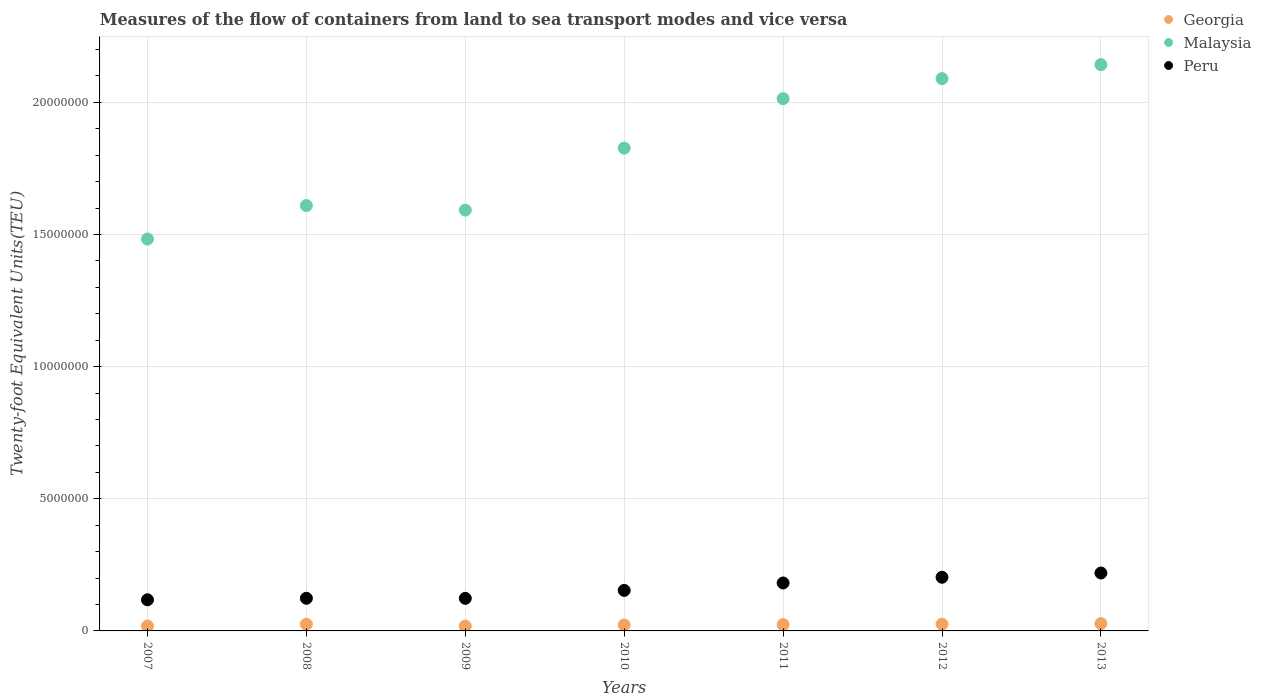How many different coloured dotlines are there?
Your answer should be very brief. 3. What is the container port traffic in Malaysia in 2013?
Your answer should be compact. 2.14e+07. Across all years, what is the maximum container port traffic in Georgia?
Offer a very short reply. 2.77e+05. Across all years, what is the minimum container port traffic in Peru?
Give a very brief answer. 1.18e+06. In which year was the container port traffic in Peru minimum?
Your response must be concise. 2007. What is the total container port traffic in Malaysia in the graph?
Offer a very short reply. 1.28e+08. What is the difference between the container port traffic in Georgia in 2010 and that in 2012?
Your answer should be very brief. -3.08e+04. What is the difference between the container port traffic in Peru in 2013 and the container port traffic in Georgia in 2007?
Ensure brevity in your answer.  2.01e+06. What is the average container port traffic in Peru per year?
Offer a terse response. 1.60e+06. In the year 2009, what is the difference between the container port traffic in Peru and container port traffic in Georgia?
Your answer should be very brief. 1.05e+06. What is the ratio of the container port traffic in Malaysia in 2010 to that in 2011?
Your answer should be compact. 0.91. Is the container port traffic in Georgia in 2010 less than that in 2011?
Keep it short and to the point. Yes. What is the difference between the highest and the second highest container port traffic in Malaysia?
Provide a succinct answer. 5.29e+05. What is the difference between the highest and the lowest container port traffic in Georgia?
Your response must be concise. 9.56e+04. In how many years, is the container port traffic in Georgia greater than the average container port traffic in Georgia taken over all years?
Provide a short and direct response. 4. Is it the case that in every year, the sum of the container port traffic in Peru and container port traffic in Malaysia  is greater than the container port traffic in Georgia?
Your response must be concise. Yes. Is the container port traffic in Georgia strictly greater than the container port traffic in Peru over the years?
Your answer should be very brief. No. How many dotlines are there?
Your answer should be compact. 3. Does the graph contain any zero values?
Make the answer very short. No. Does the graph contain grids?
Make the answer very short. Yes. Where does the legend appear in the graph?
Offer a terse response. Top right. How many legend labels are there?
Your answer should be compact. 3. What is the title of the graph?
Give a very brief answer. Measures of the flow of containers from land to sea transport modes and vice versa. What is the label or title of the Y-axis?
Offer a terse response. Twenty-foot Equivalent Units(TEU). What is the Twenty-foot Equivalent Units(TEU) of Georgia in 2007?
Provide a succinct answer. 1.85e+05. What is the Twenty-foot Equivalent Units(TEU) of Malaysia in 2007?
Keep it short and to the point. 1.48e+07. What is the Twenty-foot Equivalent Units(TEU) of Peru in 2007?
Provide a succinct answer. 1.18e+06. What is the Twenty-foot Equivalent Units(TEU) of Georgia in 2008?
Your answer should be compact. 2.54e+05. What is the Twenty-foot Equivalent Units(TEU) of Malaysia in 2008?
Offer a terse response. 1.61e+07. What is the Twenty-foot Equivalent Units(TEU) in Peru in 2008?
Offer a very short reply. 1.24e+06. What is the Twenty-foot Equivalent Units(TEU) of Georgia in 2009?
Your answer should be very brief. 1.82e+05. What is the Twenty-foot Equivalent Units(TEU) of Malaysia in 2009?
Your answer should be compact. 1.59e+07. What is the Twenty-foot Equivalent Units(TEU) in Peru in 2009?
Make the answer very short. 1.23e+06. What is the Twenty-foot Equivalent Units(TEU) of Georgia in 2010?
Provide a succinct answer. 2.26e+05. What is the Twenty-foot Equivalent Units(TEU) of Malaysia in 2010?
Provide a succinct answer. 1.83e+07. What is the Twenty-foot Equivalent Units(TEU) of Peru in 2010?
Make the answer very short. 1.53e+06. What is the Twenty-foot Equivalent Units(TEU) in Georgia in 2011?
Give a very brief answer. 2.39e+05. What is the Twenty-foot Equivalent Units(TEU) in Malaysia in 2011?
Give a very brief answer. 2.01e+07. What is the Twenty-foot Equivalent Units(TEU) of Peru in 2011?
Make the answer very short. 1.81e+06. What is the Twenty-foot Equivalent Units(TEU) of Georgia in 2012?
Offer a very short reply. 2.57e+05. What is the Twenty-foot Equivalent Units(TEU) in Malaysia in 2012?
Give a very brief answer. 2.09e+07. What is the Twenty-foot Equivalent Units(TEU) of Peru in 2012?
Provide a succinct answer. 2.03e+06. What is the Twenty-foot Equivalent Units(TEU) in Georgia in 2013?
Provide a succinct answer. 2.77e+05. What is the Twenty-foot Equivalent Units(TEU) of Malaysia in 2013?
Keep it short and to the point. 2.14e+07. What is the Twenty-foot Equivalent Units(TEU) in Peru in 2013?
Provide a short and direct response. 2.19e+06. Across all years, what is the maximum Twenty-foot Equivalent Units(TEU) of Georgia?
Your response must be concise. 2.77e+05. Across all years, what is the maximum Twenty-foot Equivalent Units(TEU) of Malaysia?
Ensure brevity in your answer.  2.14e+07. Across all years, what is the maximum Twenty-foot Equivalent Units(TEU) of Peru?
Provide a succinct answer. 2.19e+06. Across all years, what is the minimum Twenty-foot Equivalent Units(TEU) in Georgia?
Your response must be concise. 1.82e+05. Across all years, what is the minimum Twenty-foot Equivalent Units(TEU) of Malaysia?
Provide a short and direct response. 1.48e+07. Across all years, what is the minimum Twenty-foot Equivalent Units(TEU) of Peru?
Give a very brief answer. 1.18e+06. What is the total Twenty-foot Equivalent Units(TEU) of Georgia in the graph?
Give a very brief answer. 1.62e+06. What is the total Twenty-foot Equivalent Units(TEU) of Malaysia in the graph?
Offer a very short reply. 1.28e+08. What is the total Twenty-foot Equivalent Units(TEU) of Peru in the graph?
Give a very brief answer. 1.12e+07. What is the difference between the Twenty-foot Equivalent Units(TEU) of Georgia in 2007 and that in 2008?
Provide a succinct answer. -6.90e+04. What is the difference between the Twenty-foot Equivalent Units(TEU) of Malaysia in 2007 and that in 2008?
Provide a short and direct response. -1.27e+06. What is the difference between the Twenty-foot Equivalent Units(TEU) of Peru in 2007 and that in 2008?
Your response must be concise. -5.74e+04. What is the difference between the Twenty-foot Equivalent Units(TEU) of Georgia in 2007 and that in 2009?
Offer a very short reply. 3179. What is the difference between the Twenty-foot Equivalent Units(TEU) in Malaysia in 2007 and that in 2009?
Provide a short and direct response. -1.09e+06. What is the difference between the Twenty-foot Equivalent Units(TEU) of Peru in 2007 and that in 2009?
Ensure brevity in your answer.  -5.49e+04. What is the difference between the Twenty-foot Equivalent Units(TEU) of Georgia in 2007 and that in 2010?
Your answer should be very brief. -4.13e+04. What is the difference between the Twenty-foot Equivalent Units(TEU) in Malaysia in 2007 and that in 2010?
Provide a short and direct response. -3.44e+06. What is the difference between the Twenty-foot Equivalent Units(TEU) of Peru in 2007 and that in 2010?
Offer a very short reply. -3.56e+05. What is the difference between the Twenty-foot Equivalent Units(TEU) in Georgia in 2007 and that in 2011?
Give a very brief answer. -5.42e+04. What is the difference between the Twenty-foot Equivalent Units(TEU) of Malaysia in 2007 and that in 2011?
Provide a succinct answer. -5.31e+06. What is the difference between the Twenty-foot Equivalent Units(TEU) of Peru in 2007 and that in 2011?
Your answer should be very brief. -6.37e+05. What is the difference between the Twenty-foot Equivalent Units(TEU) in Georgia in 2007 and that in 2012?
Provide a short and direct response. -7.21e+04. What is the difference between the Twenty-foot Equivalent Units(TEU) of Malaysia in 2007 and that in 2012?
Provide a succinct answer. -6.07e+06. What is the difference between the Twenty-foot Equivalent Units(TEU) in Peru in 2007 and that in 2012?
Offer a terse response. -8.53e+05. What is the difference between the Twenty-foot Equivalent Units(TEU) in Georgia in 2007 and that in 2013?
Give a very brief answer. -9.24e+04. What is the difference between the Twenty-foot Equivalent Units(TEU) of Malaysia in 2007 and that in 2013?
Offer a terse response. -6.60e+06. What is the difference between the Twenty-foot Equivalent Units(TEU) in Peru in 2007 and that in 2013?
Your answer should be very brief. -1.01e+06. What is the difference between the Twenty-foot Equivalent Units(TEU) of Georgia in 2008 and that in 2009?
Your response must be concise. 7.22e+04. What is the difference between the Twenty-foot Equivalent Units(TEU) in Malaysia in 2008 and that in 2009?
Ensure brevity in your answer.  1.71e+05. What is the difference between the Twenty-foot Equivalent Units(TEU) in Peru in 2008 and that in 2009?
Ensure brevity in your answer.  2477. What is the difference between the Twenty-foot Equivalent Units(TEU) in Georgia in 2008 and that in 2010?
Your answer should be compact. 2.77e+04. What is the difference between the Twenty-foot Equivalent Units(TEU) of Malaysia in 2008 and that in 2010?
Provide a succinct answer. -2.17e+06. What is the difference between the Twenty-foot Equivalent Units(TEU) in Peru in 2008 and that in 2010?
Provide a succinct answer. -2.99e+05. What is the difference between the Twenty-foot Equivalent Units(TEU) in Georgia in 2008 and that in 2011?
Ensure brevity in your answer.  1.48e+04. What is the difference between the Twenty-foot Equivalent Units(TEU) of Malaysia in 2008 and that in 2011?
Make the answer very short. -4.05e+06. What is the difference between the Twenty-foot Equivalent Units(TEU) in Peru in 2008 and that in 2011?
Provide a succinct answer. -5.79e+05. What is the difference between the Twenty-foot Equivalent Units(TEU) in Georgia in 2008 and that in 2012?
Offer a terse response. -3117.82. What is the difference between the Twenty-foot Equivalent Units(TEU) of Malaysia in 2008 and that in 2012?
Give a very brief answer. -4.80e+06. What is the difference between the Twenty-foot Equivalent Units(TEU) in Peru in 2008 and that in 2012?
Provide a succinct answer. -7.96e+05. What is the difference between the Twenty-foot Equivalent Units(TEU) of Georgia in 2008 and that in 2013?
Offer a very short reply. -2.34e+04. What is the difference between the Twenty-foot Equivalent Units(TEU) in Malaysia in 2008 and that in 2013?
Your response must be concise. -5.33e+06. What is the difference between the Twenty-foot Equivalent Units(TEU) of Peru in 2008 and that in 2013?
Ensure brevity in your answer.  -9.56e+05. What is the difference between the Twenty-foot Equivalent Units(TEU) of Georgia in 2009 and that in 2010?
Provide a short and direct response. -4.45e+04. What is the difference between the Twenty-foot Equivalent Units(TEU) in Malaysia in 2009 and that in 2010?
Your answer should be compact. -2.34e+06. What is the difference between the Twenty-foot Equivalent Units(TEU) of Peru in 2009 and that in 2010?
Offer a terse response. -3.01e+05. What is the difference between the Twenty-foot Equivalent Units(TEU) of Georgia in 2009 and that in 2011?
Your answer should be very brief. -5.74e+04. What is the difference between the Twenty-foot Equivalent Units(TEU) of Malaysia in 2009 and that in 2011?
Make the answer very short. -4.22e+06. What is the difference between the Twenty-foot Equivalent Units(TEU) of Peru in 2009 and that in 2011?
Keep it short and to the point. -5.82e+05. What is the difference between the Twenty-foot Equivalent Units(TEU) of Georgia in 2009 and that in 2012?
Provide a short and direct response. -7.53e+04. What is the difference between the Twenty-foot Equivalent Units(TEU) in Malaysia in 2009 and that in 2012?
Offer a very short reply. -4.97e+06. What is the difference between the Twenty-foot Equivalent Units(TEU) in Peru in 2009 and that in 2012?
Offer a terse response. -7.98e+05. What is the difference between the Twenty-foot Equivalent Units(TEU) of Georgia in 2009 and that in 2013?
Offer a very short reply. -9.56e+04. What is the difference between the Twenty-foot Equivalent Units(TEU) of Malaysia in 2009 and that in 2013?
Offer a very short reply. -5.50e+06. What is the difference between the Twenty-foot Equivalent Units(TEU) of Peru in 2009 and that in 2013?
Provide a succinct answer. -9.59e+05. What is the difference between the Twenty-foot Equivalent Units(TEU) in Georgia in 2010 and that in 2011?
Make the answer very short. -1.29e+04. What is the difference between the Twenty-foot Equivalent Units(TEU) in Malaysia in 2010 and that in 2011?
Keep it short and to the point. -1.87e+06. What is the difference between the Twenty-foot Equivalent Units(TEU) in Peru in 2010 and that in 2011?
Give a very brief answer. -2.81e+05. What is the difference between the Twenty-foot Equivalent Units(TEU) in Georgia in 2010 and that in 2012?
Make the answer very short. -3.08e+04. What is the difference between the Twenty-foot Equivalent Units(TEU) of Malaysia in 2010 and that in 2012?
Provide a short and direct response. -2.63e+06. What is the difference between the Twenty-foot Equivalent Units(TEU) of Peru in 2010 and that in 2012?
Ensure brevity in your answer.  -4.97e+05. What is the difference between the Twenty-foot Equivalent Units(TEU) in Georgia in 2010 and that in 2013?
Ensure brevity in your answer.  -5.11e+04. What is the difference between the Twenty-foot Equivalent Units(TEU) in Malaysia in 2010 and that in 2013?
Provide a succinct answer. -3.16e+06. What is the difference between the Twenty-foot Equivalent Units(TEU) of Peru in 2010 and that in 2013?
Keep it short and to the point. -6.58e+05. What is the difference between the Twenty-foot Equivalent Units(TEU) of Georgia in 2011 and that in 2012?
Your answer should be very brief. -1.79e+04. What is the difference between the Twenty-foot Equivalent Units(TEU) in Malaysia in 2011 and that in 2012?
Offer a very short reply. -7.58e+05. What is the difference between the Twenty-foot Equivalent Units(TEU) in Peru in 2011 and that in 2012?
Your answer should be compact. -2.16e+05. What is the difference between the Twenty-foot Equivalent Units(TEU) of Georgia in 2011 and that in 2013?
Give a very brief answer. -3.82e+04. What is the difference between the Twenty-foot Equivalent Units(TEU) in Malaysia in 2011 and that in 2013?
Make the answer very short. -1.29e+06. What is the difference between the Twenty-foot Equivalent Units(TEU) of Peru in 2011 and that in 2013?
Offer a terse response. -3.77e+05. What is the difference between the Twenty-foot Equivalent Units(TEU) in Georgia in 2012 and that in 2013?
Keep it short and to the point. -2.03e+04. What is the difference between the Twenty-foot Equivalent Units(TEU) of Malaysia in 2012 and that in 2013?
Offer a very short reply. -5.29e+05. What is the difference between the Twenty-foot Equivalent Units(TEU) in Peru in 2012 and that in 2013?
Offer a terse response. -1.60e+05. What is the difference between the Twenty-foot Equivalent Units(TEU) in Georgia in 2007 and the Twenty-foot Equivalent Units(TEU) in Malaysia in 2008?
Your response must be concise. -1.59e+07. What is the difference between the Twenty-foot Equivalent Units(TEU) of Georgia in 2007 and the Twenty-foot Equivalent Units(TEU) of Peru in 2008?
Provide a succinct answer. -1.05e+06. What is the difference between the Twenty-foot Equivalent Units(TEU) in Malaysia in 2007 and the Twenty-foot Equivalent Units(TEU) in Peru in 2008?
Provide a succinct answer. 1.36e+07. What is the difference between the Twenty-foot Equivalent Units(TEU) in Georgia in 2007 and the Twenty-foot Equivalent Units(TEU) in Malaysia in 2009?
Your answer should be compact. -1.57e+07. What is the difference between the Twenty-foot Equivalent Units(TEU) in Georgia in 2007 and the Twenty-foot Equivalent Units(TEU) in Peru in 2009?
Make the answer very short. -1.05e+06. What is the difference between the Twenty-foot Equivalent Units(TEU) in Malaysia in 2007 and the Twenty-foot Equivalent Units(TEU) in Peru in 2009?
Offer a terse response. 1.36e+07. What is the difference between the Twenty-foot Equivalent Units(TEU) of Georgia in 2007 and the Twenty-foot Equivalent Units(TEU) of Malaysia in 2010?
Provide a succinct answer. -1.81e+07. What is the difference between the Twenty-foot Equivalent Units(TEU) of Georgia in 2007 and the Twenty-foot Equivalent Units(TEU) of Peru in 2010?
Provide a short and direct response. -1.35e+06. What is the difference between the Twenty-foot Equivalent Units(TEU) in Malaysia in 2007 and the Twenty-foot Equivalent Units(TEU) in Peru in 2010?
Offer a terse response. 1.33e+07. What is the difference between the Twenty-foot Equivalent Units(TEU) in Georgia in 2007 and the Twenty-foot Equivalent Units(TEU) in Malaysia in 2011?
Provide a succinct answer. -2.00e+07. What is the difference between the Twenty-foot Equivalent Units(TEU) of Georgia in 2007 and the Twenty-foot Equivalent Units(TEU) of Peru in 2011?
Provide a short and direct response. -1.63e+06. What is the difference between the Twenty-foot Equivalent Units(TEU) in Malaysia in 2007 and the Twenty-foot Equivalent Units(TEU) in Peru in 2011?
Your response must be concise. 1.30e+07. What is the difference between the Twenty-foot Equivalent Units(TEU) of Georgia in 2007 and the Twenty-foot Equivalent Units(TEU) of Malaysia in 2012?
Keep it short and to the point. -2.07e+07. What is the difference between the Twenty-foot Equivalent Units(TEU) in Georgia in 2007 and the Twenty-foot Equivalent Units(TEU) in Peru in 2012?
Offer a terse response. -1.85e+06. What is the difference between the Twenty-foot Equivalent Units(TEU) in Malaysia in 2007 and the Twenty-foot Equivalent Units(TEU) in Peru in 2012?
Your answer should be very brief. 1.28e+07. What is the difference between the Twenty-foot Equivalent Units(TEU) in Georgia in 2007 and the Twenty-foot Equivalent Units(TEU) in Malaysia in 2013?
Offer a terse response. -2.12e+07. What is the difference between the Twenty-foot Equivalent Units(TEU) of Georgia in 2007 and the Twenty-foot Equivalent Units(TEU) of Peru in 2013?
Ensure brevity in your answer.  -2.01e+06. What is the difference between the Twenty-foot Equivalent Units(TEU) of Malaysia in 2007 and the Twenty-foot Equivalent Units(TEU) of Peru in 2013?
Make the answer very short. 1.26e+07. What is the difference between the Twenty-foot Equivalent Units(TEU) in Georgia in 2008 and the Twenty-foot Equivalent Units(TEU) in Malaysia in 2009?
Keep it short and to the point. -1.57e+07. What is the difference between the Twenty-foot Equivalent Units(TEU) in Georgia in 2008 and the Twenty-foot Equivalent Units(TEU) in Peru in 2009?
Give a very brief answer. -9.79e+05. What is the difference between the Twenty-foot Equivalent Units(TEU) in Malaysia in 2008 and the Twenty-foot Equivalent Units(TEU) in Peru in 2009?
Provide a short and direct response. 1.49e+07. What is the difference between the Twenty-foot Equivalent Units(TEU) of Georgia in 2008 and the Twenty-foot Equivalent Units(TEU) of Malaysia in 2010?
Provide a short and direct response. -1.80e+07. What is the difference between the Twenty-foot Equivalent Units(TEU) in Georgia in 2008 and the Twenty-foot Equivalent Units(TEU) in Peru in 2010?
Offer a terse response. -1.28e+06. What is the difference between the Twenty-foot Equivalent Units(TEU) in Malaysia in 2008 and the Twenty-foot Equivalent Units(TEU) in Peru in 2010?
Offer a very short reply. 1.46e+07. What is the difference between the Twenty-foot Equivalent Units(TEU) in Georgia in 2008 and the Twenty-foot Equivalent Units(TEU) in Malaysia in 2011?
Offer a very short reply. -1.99e+07. What is the difference between the Twenty-foot Equivalent Units(TEU) of Georgia in 2008 and the Twenty-foot Equivalent Units(TEU) of Peru in 2011?
Provide a succinct answer. -1.56e+06. What is the difference between the Twenty-foot Equivalent Units(TEU) in Malaysia in 2008 and the Twenty-foot Equivalent Units(TEU) in Peru in 2011?
Ensure brevity in your answer.  1.43e+07. What is the difference between the Twenty-foot Equivalent Units(TEU) in Georgia in 2008 and the Twenty-foot Equivalent Units(TEU) in Malaysia in 2012?
Offer a very short reply. -2.06e+07. What is the difference between the Twenty-foot Equivalent Units(TEU) in Georgia in 2008 and the Twenty-foot Equivalent Units(TEU) in Peru in 2012?
Your response must be concise. -1.78e+06. What is the difference between the Twenty-foot Equivalent Units(TEU) of Malaysia in 2008 and the Twenty-foot Equivalent Units(TEU) of Peru in 2012?
Your answer should be compact. 1.41e+07. What is the difference between the Twenty-foot Equivalent Units(TEU) in Georgia in 2008 and the Twenty-foot Equivalent Units(TEU) in Malaysia in 2013?
Provide a succinct answer. -2.12e+07. What is the difference between the Twenty-foot Equivalent Units(TEU) in Georgia in 2008 and the Twenty-foot Equivalent Units(TEU) in Peru in 2013?
Ensure brevity in your answer.  -1.94e+06. What is the difference between the Twenty-foot Equivalent Units(TEU) of Malaysia in 2008 and the Twenty-foot Equivalent Units(TEU) of Peru in 2013?
Keep it short and to the point. 1.39e+07. What is the difference between the Twenty-foot Equivalent Units(TEU) in Georgia in 2009 and the Twenty-foot Equivalent Units(TEU) in Malaysia in 2010?
Make the answer very short. -1.81e+07. What is the difference between the Twenty-foot Equivalent Units(TEU) in Georgia in 2009 and the Twenty-foot Equivalent Units(TEU) in Peru in 2010?
Provide a succinct answer. -1.35e+06. What is the difference between the Twenty-foot Equivalent Units(TEU) in Malaysia in 2009 and the Twenty-foot Equivalent Units(TEU) in Peru in 2010?
Offer a terse response. 1.44e+07. What is the difference between the Twenty-foot Equivalent Units(TEU) of Georgia in 2009 and the Twenty-foot Equivalent Units(TEU) of Malaysia in 2011?
Keep it short and to the point. -2.00e+07. What is the difference between the Twenty-foot Equivalent Units(TEU) in Georgia in 2009 and the Twenty-foot Equivalent Units(TEU) in Peru in 2011?
Make the answer very short. -1.63e+06. What is the difference between the Twenty-foot Equivalent Units(TEU) of Malaysia in 2009 and the Twenty-foot Equivalent Units(TEU) of Peru in 2011?
Your answer should be compact. 1.41e+07. What is the difference between the Twenty-foot Equivalent Units(TEU) in Georgia in 2009 and the Twenty-foot Equivalent Units(TEU) in Malaysia in 2012?
Keep it short and to the point. -2.07e+07. What is the difference between the Twenty-foot Equivalent Units(TEU) in Georgia in 2009 and the Twenty-foot Equivalent Units(TEU) in Peru in 2012?
Give a very brief answer. -1.85e+06. What is the difference between the Twenty-foot Equivalent Units(TEU) in Malaysia in 2009 and the Twenty-foot Equivalent Units(TEU) in Peru in 2012?
Keep it short and to the point. 1.39e+07. What is the difference between the Twenty-foot Equivalent Units(TEU) in Georgia in 2009 and the Twenty-foot Equivalent Units(TEU) in Malaysia in 2013?
Your response must be concise. -2.12e+07. What is the difference between the Twenty-foot Equivalent Units(TEU) of Georgia in 2009 and the Twenty-foot Equivalent Units(TEU) of Peru in 2013?
Your response must be concise. -2.01e+06. What is the difference between the Twenty-foot Equivalent Units(TEU) in Malaysia in 2009 and the Twenty-foot Equivalent Units(TEU) in Peru in 2013?
Make the answer very short. 1.37e+07. What is the difference between the Twenty-foot Equivalent Units(TEU) of Georgia in 2010 and the Twenty-foot Equivalent Units(TEU) of Malaysia in 2011?
Make the answer very short. -1.99e+07. What is the difference between the Twenty-foot Equivalent Units(TEU) in Georgia in 2010 and the Twenty-foot Equivalent Units(TEU) in Peru in 2011?
Ensure brevity in your answer.  -1.59e+06. What is the difference between the Twenty-foot Equivalent Units(TEU) of Malaysia in 2010 and the Twenty-foot Equivalent Units(TEU) of Peru in 2011?
Your answer should be very brief. 1.65e+07. What is the difference between the Twenty-foot Equivalent Units(TEU) of Georgia in 2010 and the Twenty-foot Equivalent Units(TEU) of Malaysia in 2012?
Your answer should be compact. -2.07e+07. What is the difference between the Twenty-foot Equivalent Units(TEU) of Georgia in 2010 and the Twenty-foot Equivalent Units(TEU) of Peru in 2012?
Offer a very short reply. -1.81e+06. What is the difference between the Twenty-foot Equivalent Units(TEU) in Malaysia in 2010 and the Twenty-foot Equivalent Units(TEU) in Peru in 2012?
Keep it short and to the point. 1.62e+07. What is the difference between the Twenty-foot Equivalent Units(TEU) of Georgia in 2010 and the Twenty-foot Equivalent Units(TEU) of Malaysia in 2013?
Offer a terse response. -2.12e+07. What is the difference between the Twenty-foot Equivalent Units(TEU) of Georgia in 2010 and the Twenty-foot Equivalent Units(TEU) of Peru in 2013?
Offer a very short reply. -1.97e+06. What is the difference between the Twenty-foot Equivalent Units(TEU) of Malaysia in 2010 and the Twenty-foot Equivalent Units(TEU) of Peru in 2013?
Offer a terse response. 1.61e+07. What is the difference between the Twenty-foot Equivalent Units(TEU) of Georgia in 2011 and the Twenty-foot Equivalent Units(TEU) of Malaysia in 2012?
Provide a succinct answer. -2.07e+07. What is the difference between the Twenty-foot Equivalent Units(TEU) in Georgia in 2011 and the Twenty-foot Equivalent Units(TEU) in Peru in 2012?
Offer a very short reply. -1.79e+06. What is the difference between the Twenty-foot Equivalent Units(TEU) of Malaysia in 2011 and the Twenty-foot Equivalent Units(TEU) of Peru in 2012?
Make the answer very short. 1.81e+07. What is the difference between the Twenty-foot Equivalent Units(TEU) in Georgia in 2011 and the Twenty-foot Equivalent Units(TEU) in Malaysia in 2013?
Provide a short and direct response. -2.12e+07. What is the difference between the Twenty-foot Equivalent Units(TEU) in Georgia in 2011 and the Twenty-foot Equivalent Units(TEU) in Peru in 2013?
Offer a terse response. -1.95e+06. What is the difference between the Twenty-foot Equivalent Units(TEU) in Malaysia in 2011 and the Twenty-foot Equivalent Units(TEU) in Peru in 2013?
Offer a terse response. 1.79e+07. What is the difference between the Twenty-foot Equivalent Units(TEU) in Georgia in 2012 and the Twenty-foot Equivalent Units(TEU) in Malaysia in 2013?
Your response must be concise. -2.12e+07. What is the difference between the Twenty-foot Equivalent Units(TEU) in Georgia in 2012 and the Twenty-foot Equivalent Units(TEU) in Peru in 2013?
Provide a short and direct response. -1.93e+06. What is the difference between the Twenty-foot Equivalent Units(TEU) in Malaysia in 2012 and the Twenty-foot Equivalent Units(TEU) in Peru in 2013?
Keep it short and to the point. 1.87e+07. What is the average Twenty-foot Equivalent Units(TEU) of Georgia per year?
Offer a terse response. 2.31e+05. What is the average Twenty-foot Equivalent Units(TEU) in Malaysia per year?
Give a very brief answer. 1.82e+07. What is the average Twenty-foot Equivalent Units(TEU) of Peru per year?
Your answer should be very brief. 1.60e+06. In the year 2007, what is the difference between the Twenty-foot Equivalent Units(TEU) in Georgia and Twenty-foot Equivalent Units(TEU) in Malaysia?
Offer a very short reply. -1.46e+07. In the year 2007, what is the difference between the Twenty-foot Equivalent Units(TEU) of Georgia and Twenty-foot Equivalent Units(TEU) of Peru?
Ensure brevity in your answer.  -9.93e+05. In the year 2007, what is the difference between the Twenty-foot Equivalent Units(TEU) in Malaysia and Twenty-foot Equivalent Units(TEU) in Peru?
Your answer should be compact. 1.37e+07. In the year 2008, what is the difference between the Twenty-foot Equivalent Units(TEU) of Georgia and Twenty-foot Equivalent Units(TEU) of Malaysia?
Your response must be concise. -1.58e+07. In the year 2008, what is the difference between the Twenty-foot Equivalent Units(TEU) in Georgia and Twenty-foot Equivalent Units(TEU) in Peru?
Your response must be concise. -9.82e+05. In the year 2008, what is the difference between the Twenty-foot Equivalent Units(TEU) in Malaysia and Twenty-foot Equivalent Units(TEU) in Peru?
Make the answer very short. 1.49e+07. In the year 2009, what is the difference between the Twenty-foot Equivalent Units(TEU) of Georgia and Twenty-foot Equivalent Units(TEU) of Malaysia?
Your answer should be very brief. -1.57e+07. In the year 2009, what is the difference between the Twenty-foot Equivalent Units(TEU) in Georgia and Twenty-foot Equivalent Units(TEU) in Peru?
Offer a very short reply. -1.05e+06. In the year 2009, what is the difference between the Twenty-foot Equivalent Units(TEU) in Malaysia and Twenty-foot Equivalent Units(TEU) in Peru?
Your answer should be very brief. 1.47e+07. In the year 2010, what is the difference between the Twenty-foot Equivalent Units(TEU) in Georgia and Twenty-foot Equivalent Units(TEU) in Malaysia?
Give a very brief answer. -1.80e+07. In the year 2010, what is the difference between the Twenty-foot Equivalent Units(TEU) of Georgia and Twenty-foot Equivalent Units(TEU) of Peru?
Ensure brevity in your answer.  -1.31e+06. In the year 2010, what is the difference between the Twenty-foot Equivalent Units(TEU) in Malaysia and Twenty-foot Equivalent Units(TEU) in Peru?
Make the answer very short. 1.67e+07. In the year 2011, what is the difference between the Twenty-foot Equivalent Units(TEU) of Georgia and Twenty-foot Equivalent Units(TEU) of Malaysia?
Provide a succinct answer. -1.99e+07. In the year 2011, what is the difference between the Twenty-foot Equivalent Units(TEU) in Georgia and Twenty-foot Equivalent Units(TEU) in Peru?
Offer a terse response. -1.58e+06. In the year 2011, what is the difference between the Twenty-foot Equivalent Units(TEU) in Malaysia and Twenty-foot Equivalent Units(TEU) in Peru?
Offer a terse response. 1.83e+07. In the year 2012, what is the difference between the Twenty-foot Equivalent Units(TEU) in Georgia and Twenty-foot Equivalent Units(TEU) in Malaysia?
Make the answer very short. -2.06e+07. In the year 2012, what is the difference between the Twenty-foot Equivalent Units(TEU) in Georgia and Twenty-foot Equivalent Units(TEU) in Peru?
Offer a very short reply. -1.77e+06. In the year 2012, what is the difference between the Twenty-foot Equivalent Units(TEU) in Malaysia and Twenty-foot Equivalent Units(TEU) in Peru?
Your response must be concise. 1.89e+07. In the year 2013, what is the difference between the Twenty-foot Equivalent Units(TEU) in Georgia and Twenty-foot Equivalent Units(TEU) in Malaysia?
Offer a terse response. -2.11e+07. In the year 2013, what is the difference between the Twenty-foot Equivalent Units(TEU) in Georgia and Twenty-foot Equivalent Units(TEU) in Peru?
Your answer should be very brief. -1.91e+06. In the year 2013, what is the difference between the Twenty-foot Equivalent Units(TEU) of Malaysia and Twenty-foot Equivalent Units(TEU) of Peru?
Provide a short and direct response. 1.92e+07. What is the ratio of the Twenty-foot Equivalent Units(TEU) of Georgia in 2007 to that in 2008?
Provide a succinct answer. 0.73. What is the ratio of the Twenty-foot Equivalent Units(TEU) in Malaysia in 2007 to that in 2008?
Offer a very short reply. 0.92. What is the ratio of the Twenty-foot Equivalent Units(TEU) of Peru in 2007 to that in 2008?
Offer a terse response. 0.95. What is the ratio of the Twenty-foot Equivalent Units(TEU) of Georgia in 2007 to that in 2009?
Your response must be concise. 1.02. What is the ratio of the Twenty-foot Equivalent Units(TEU) of Malaysia in 2007 to that in 2009?
Provide a short and direct response. 0.93. What is the ratio of the Twenty-foot Equivalent Units(TEU) in Peru in 2007 to that in 2009?
Your answer should be compact. 0.96. What is the ratio of the Twenty-foot Equivalent Units(TEU) of Georgia in 2007 to that in 2010?
Provide a short and direct response. 0.82. What is the ratio of the Twenty-foot Equivalent Units(TEU) in Malaysia in 2007 to that in 2010?
Provide a succinct answer. 0.81. What is the ratio of the Twenty-foot Equivalent Units(TEU) of Peru in 2007 to that in 2010?
Your answer should be very brief. 0.77. What is the ratio of the Twenty-foot Equivalent Units(TEU) in Georgia in 2007 to that in 2011?
Give a very brief answer. 0.77. What is the ratio of the Twenty-foot Equivalent Units(TEU) in Malaysia in 2007 to that in 2011?
Offer a terse response. 0.74. What is the ratio of the Twenty-foot Equivalent Units(TEU) in Peru in 2007 to that in 2011?
Your response must be concise. 0.65. What is the ratio of the Twenty-foot Equivalent Units(TEU) in Georgia in 2007 to that in 2012?
Offer a terse response. 0.72. What is the ratio of the Twenty-foot Equivalent Units(TEU) of Malaysia in 2007 to that in 2012?
Provide a succinct answer. 0.71. What is the ratio of the Twenty-foot Equivalent Units(TEU) of Peru in 2007 to that in 2012?
Ensure brevity in your answer.  0.58. What is the ratio of the Twenty-foot Equivalent Units(TEU) in Georgia in 2007 to that in 2013?
Your response must be concise. 0.67. What is the ratio of the Twenty-foot Equivalent Units(TEU) in Malaysia in 2007 to that in 2013?
Make the answer very short. 0.69. What is the ratio of the Twenty-foot Equivalent Units(TEU) of Peru in 2007 to that in 2013?
Keep it short and to the point. 0.54. What is the ratio of the Twenty-foot Equivalent Units(TEU) of Georgia in 2008 to that in 2009?
Offer a very short reply. 1.4. What is the ratio of the Twenty-foot Equivalent Units(TEU) in Malaysia in 2008 to that in 2009?
Your answer should be compact. 1.01. What is the ratio of the Twenty-foot Equivalent Units(TEU) of Georgia in 2008 to that in 2010?
Provide a succinct answer. 1.12. What is the ratio of the Twenty-foot Equivalent Units(TEU) in Malaysia in 2008 to that in 2010?
Your response must be concise. 0.88. What is the ratio of the Twenty-foot Equivalent Units(TEU) of Peru in 2008 to that in 2010?
Your answer should be very brief. 0.81. What is the ratio of the Twenty-foot Equivalent Units(TEU) of Georgia in 2008 to that in 2011?
Provide a short and direct response. 1.06. What is the ratio of the Twenty-foot Equivalent Units(TEU) of Malaysia in 2008 to that in 2011?
Give a very brief answer. 0.8. What is the ratio of the Twenty-foot Equivalent Units(TEU) in Peru in 2008 to that in 2011?
Give a very brief answer. 0.68. What is the ratio of the Twenty-foot Equivalent Units(TEU) of Georgia in 2008 to that in 2012?
Your answer should be compact. 0.99. What is the ratio of the Twenty-foot Equivalent Units(TEU) of Malaysia in 2008 to that in 2012?
Ensure brevity in your answer.  0.77. What is the ratio of the Twenty-foot Equivalent Units(TEU) in Peru in 2008 to that in 2012?
Your answer should be compact. 0.61. What is the ratio of the Twenty-foot Equivalent Units(TEU) of Georgia in 2008 to that in 2013?
Your answer should be compact. 0.92. What is the ratio of the Twenty-foot Equivalent Units(TEU) of Malaysia in 2008 to that in 2013?
Offer a terse response. 0.75. What is the ratio of the Twenty-foot Equivalent Units(TEU) in Peru in 2008 to that in 2013?
Your response must be concise. 0.56. What is the ratio of the Twenty-foot Equivalent Units(TEU) in Georgia in 2009 to that in 2010?
Offer a terse response. 0.8. What is the ratio of the Twenty-foot Equivalent Units(TEU) of Malaysia in 2009 to that in 2010?
Your response must be concise. 0.87. What is the ratio of the Twenty-foot Equivalent Units(TEU) of Peru in 2009 to that in 2010?
Offer a terse response. 0.8. What is the ratio of the Twenty-foot Equivalent Units(TEU) of Georgia in 2009 to that in 2011?
Provide a short and direct response. 0.76. What is the ratio of the Twenty-foot Equivalent Units(TEU) of Malaysia in 2009 to that in 2011?
Give a very brief answer. 0.79. What is the ratio of the Twenty-foot Equivalent Units(TEU) in Peru in 2009 to that in 2011?
Offer a terse response. 0.68. What is the ratio of the Twenty-foot Equivalent Units(TEU) of Georgia in 2009 to that in 2012?
Provide a succinct answer. 0.71. What is the ratio of the Twenty-foot Equivalent Units(TEU) of Malaysia in 2009 to that in 2012?
Ensure brevity in your answer.  0.76. What is the ratio of the Twenty-foot Equivalent Units(TEU) of Peru in 2009 to that in 2012?
Offer a terse response. 0.61. What is the ratio of the Twenty-foot Equivalent Units(TEU) in Georgia in 2009 to that in 2013?
Offer a terse response. 0.66. What is the ratio of the Twenty-foot Equivalent Units(TEU) of Malaysia in 2009 to that in 2013?
Ensure brevity in your answer.  0.74. What is the ratio of the Twenty-foot Equivalent Units(TEU) of Peru in 2009 to that in 2013?
Provide a short and direct response. 0.56. What is the ratio of the Twenty-foot Equivalent Units(TEU) in Georgia in 2010 to that in 2011?
Make the answer very short. 0.95. What is the ratio of the Twenty-foot Equivalent Units(TEU) in Malaysia in 2010 to that in 2011?
Your answer should be compact. 0.91. What is the ratio of the Twenty-foot Equivalent Units(TEU) in Peru in 2010 to that in 2011?
Your response must be concise. 0.85. What is the ratio of the Twenty-foot Equivalent Units(TEU) in Georgia in 2010 to that in 2012?
Keep it short and to the point. 0.88. What is the ratio of the Twenty-foot Equivalent Units(TEU) in Malaysia in 2010 to that in 2012?
Your response must be concise. 0.87. What is the ratio of the Twenty-foot Equivalent Units(TEU) of Peru in 2010 to that in 2012?
Your answer should be very brief. 0.76. What is the ratio of the Twenty-foot Equivalent Units(TEU) of Georgia in 2010 to that in 2013?
Your answer should be compact. 0.82. What is the ratio of the Twenty-foot Equivalent Units(TEU) of Malaysia in 2010 to that in 2013?
Your answer should be very brief. 0.85. What is the ratio of the Twenty-foot Equivalent Units(TEU) in Peru in 2010 to that in 2013?
Give a very brief answer. 0.7. What is the ratio of the Twenty-foot Equivalent Units(TEU) of Georgia in 2011 to that in 2012?
Keep it short and to the point. 0.93. What is the ratio of the Twenty-foot Equivalent Units(TEU) of Malaysia in 2011 to that in 2012?
Give a very brief answer. 0.96. What is the ratio of the Twenty-foot Equivalent Units(TEU) of Peru in 2011 to that in 2012?
Make the answer very short. 0.89. What is the ratio of the Twenty-foot Equivalent Units(TEU) in Georgia in 2011 to that in 2013?
Ensure brevity in your answer.  0.86. What is the ratio of the Twenty-foot Equivalent Units(TEU) of Malaysia in 2011 to that in 2013?
Your response must be concise. 0.94. What is the ratio of the Twenty-foot Equivalent Units(TEU) in Peru in 2011 to that in 2013?
Ensure brevity in your answer.  0.83. What is the ratio of the Twenty-foot Equivalent Units(TEU) of Georgia in 2012 to that in 2013?
Your answer should be compact. 0.93. What is the ratio of the Twenty-foot Equivalent Units(TEU) in Malaysia in 2012 to that in 2013?
Offer a terse response. 0.98. What is the ratio of the Twenty-foot Equivalent Units(TEU) in Peru in 2012 to that in 2013?
Make the answer very short. 0.93. What is the difference between the highest and the second highest Twenty-foot Equivalent Units(TEU) in Georgia?
Offer a very short reply. 2.03e+04. What is the difference between the highest and the second highest Twenty-foot Equivalent Units(TEU) in Malaysia?
Ensure brevity in your answer.  5.29e+05. What is the difference between the highest and the second highest Twenty-foot Equivalent Units(TEU) in Peru?
Provide a short and direct response. 1.60e+05. What is the difference between the highest and the lowest Twenty-foot Equivalent Units(TEU) of Georgia?
Your response must be concise. 9.56e+04. What is the difference between the highest and the lowest Twenty-foot Equivalent Units(TEU) in Malaysia?
Keep it short and to the point. 6.60e+06. What is the difference between the highest and the lowest Twenty-foot Equivalent Units(TEU) in Peru?
Make the answer very short. 1.01e+06. 